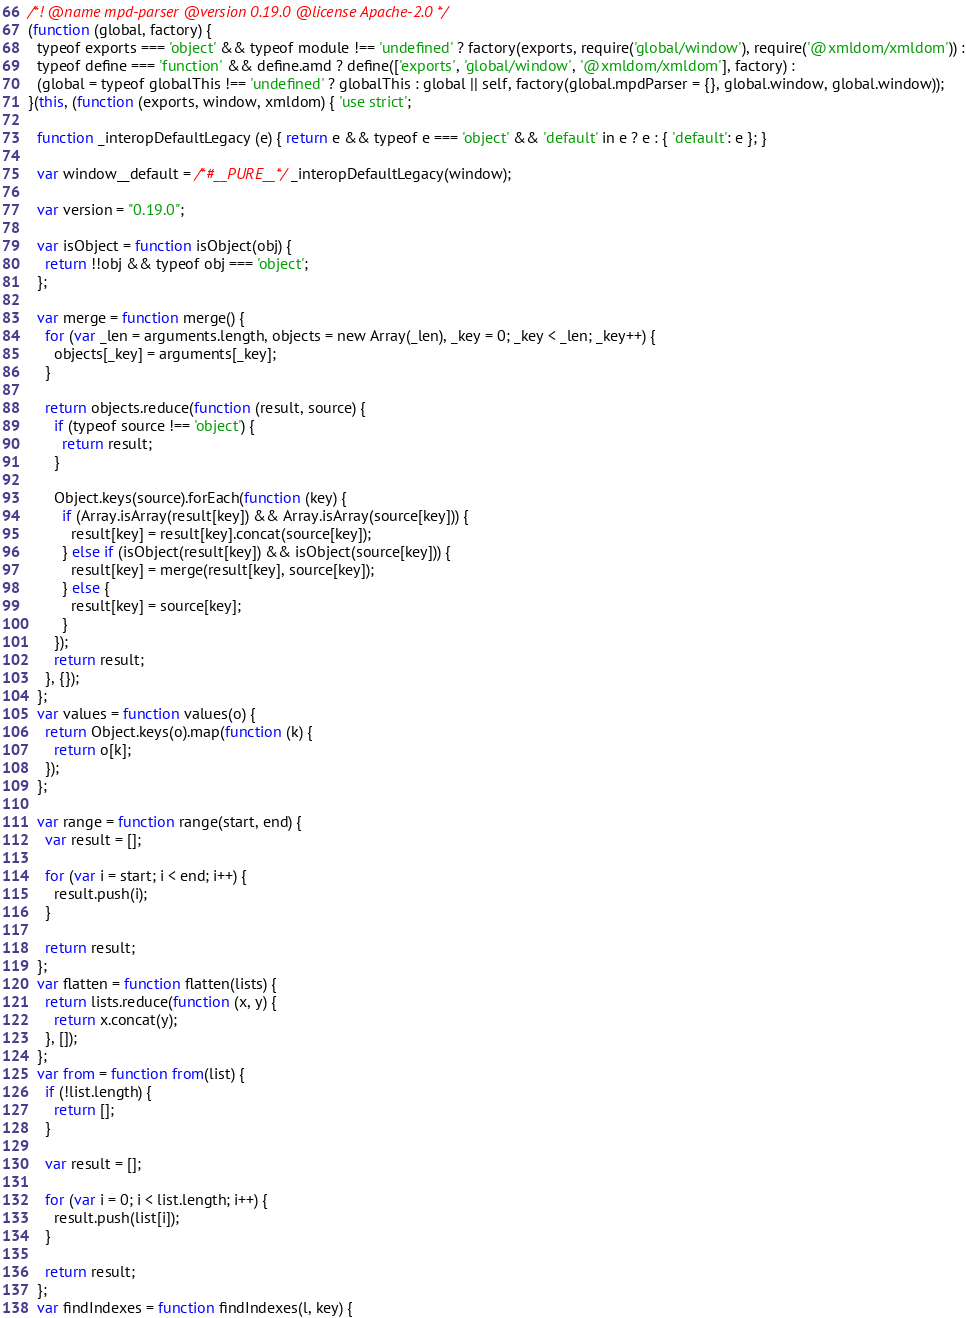<code> <loc_0><loc_0><loc_500><loc_500><_JavaScript_>/*! @name mpd-parser @version 0.19.0 @license Apache-2.0 */
(function (global, factory) {
  typeof exports === 'object' && typeof module !== 'undefined' ? factory(exports, require('global/window'), require('@xmldom/xmldom')) :
  typeof define === 'function' && define.amd ? define(['exports', 'global/window', '@xmldom/xmldom'], factory) :
  (global = typeof globalThis !== 'undefined' ? globalThis : global || self, factory(global.mpdParser = {}, global.window, global.window));
}(this, (function (exports, window, xmldom) { 'use strict';

  function _interopDefaultLegacy (e) { return e && typeof e === 'object' && 'default' in e ? e : { 'default': e }; }

  var window__default = /*#__PURE__*/_interopDefaultLegacy(window);

  var version = "0.19.0";

  var isObject = function isObject(obj) {
    return !!obj && typeof obj === 'object';
  };

  var merge = function merge() {
    for (var _len = arguments.length, objects = new Array(_len), _key = 0; _key < _len; _key++) {
      objects[_key] = arguments[_key];
    }

    return objects.reduce(function (result, source) {
      if (typeof source !== 'object') {
        return result;
      }

      Object.keys(source).forEach(function (key) {
        if (Array.isArray(result[key]) && Array.isArray(source[key])) {
          result[key] = result[key].concat(source[key]);
        } else if (isObject(result[key]) && isObject(source[key])) {
          result[key] = merge(result[key], source[key]);
        } else {
          result[key] = source[key];
        }
      });
      return result;
    }, {});
  };
  var values = function values(o) {
    return Object.keys(o).map(function (k) {
      return o[k];
    });
  };

  var range = function range(start, end) {
    var result = [];

    for (var i = start; i < end; i++) {
      result.push(i);
    }

    return result;
  };
  var flatten = function flatten(lists) {
    return lists.reduce(function (x, y) {
      return x.concat(y);
    }, []);
  };
  var from = function from(list) {
    if (!list.length) {
      return [];
    }

    var result = [];

    for (var i = 0; i < list.length; i++) {
      result.push(list[i]);
    }

    return result;
  };
  var findIndexes = function findIndexes(l, key) {</code> 